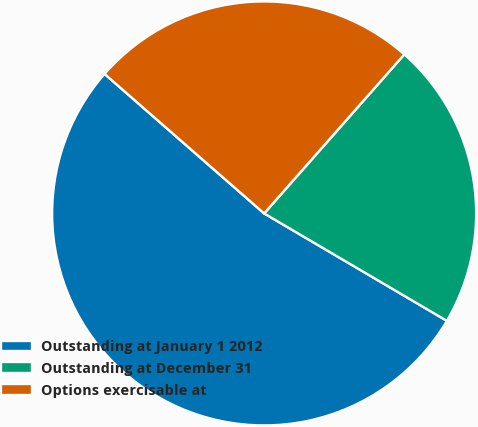Convert chart to OTSL. <chart><loc_0><loc_0><loc_500><loc_500><pie_chart><fcel>Outstanding at January 1 2012<fcel>Outstanding at December 31<fcel>Options exercisable at<nl><fcel>52.97%<fcel>21.96%<fcel>25.06%<nl></chart> 